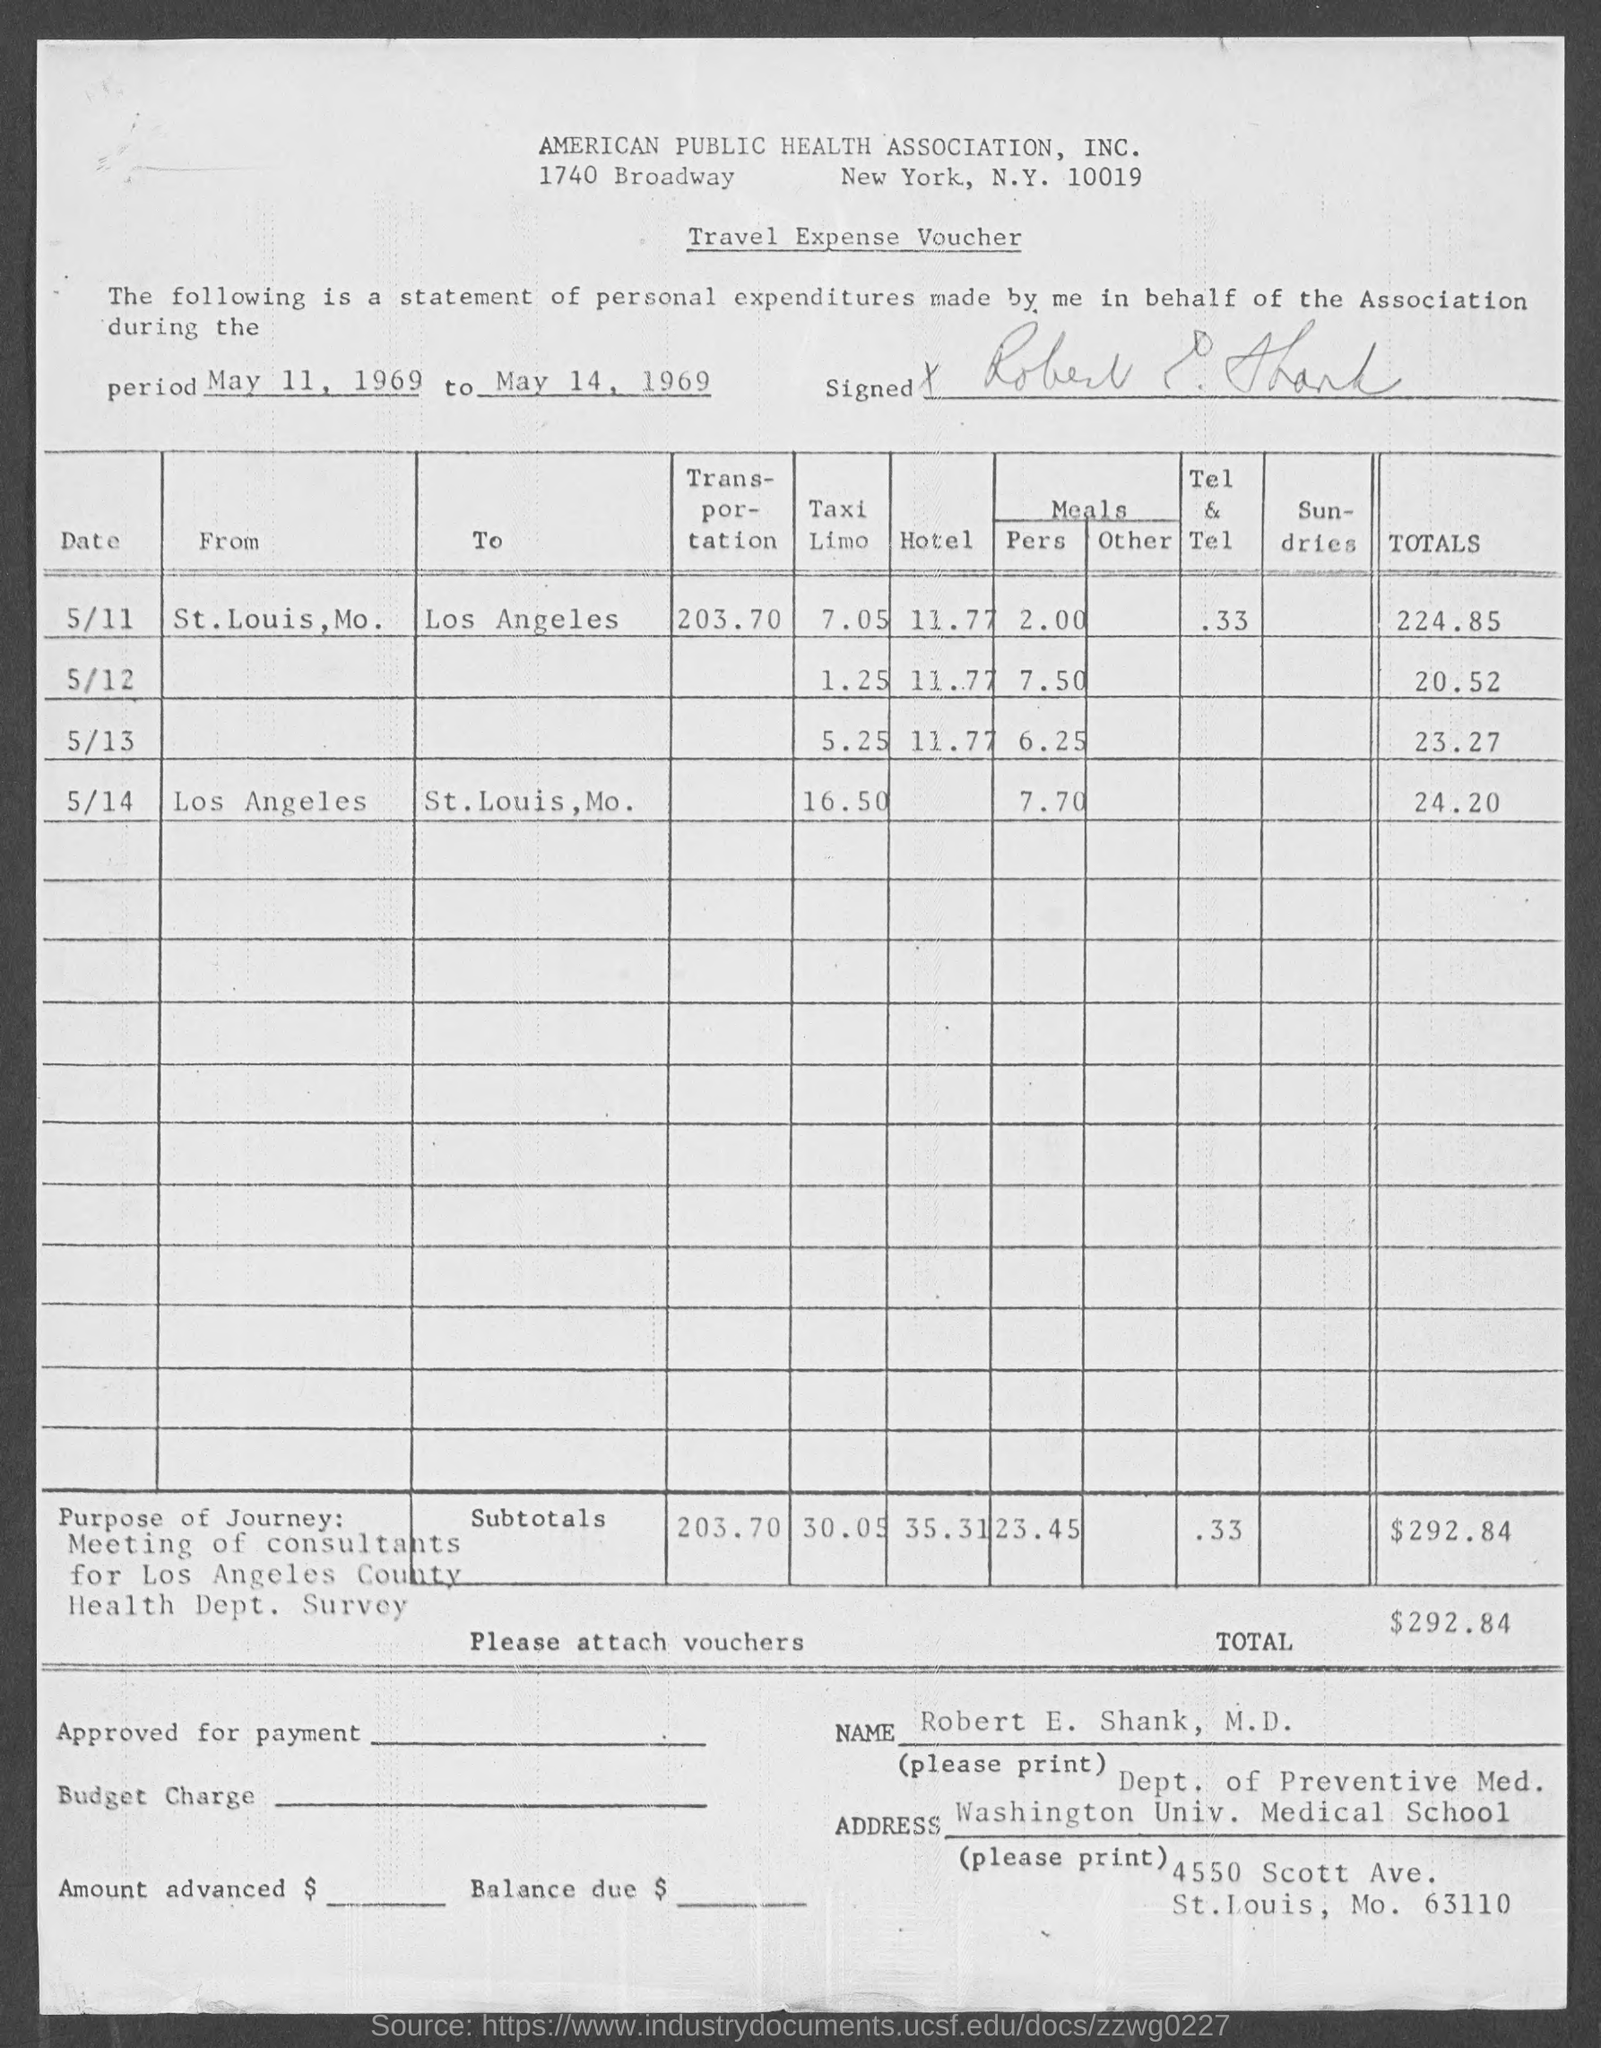What is the name of the voucher?
Your answer should be very brief. Travel Expense Voucher. What is the total amount ?
Offer a terse response. $292.84. To which department does Robert E. Shank, M.D. belong ?
Offer a very short reply. Dept. of Preventive Med. What is the period for which the statement is relevant to ?
Make the answer very short. May 11, 1969 to May 14, 1969. 